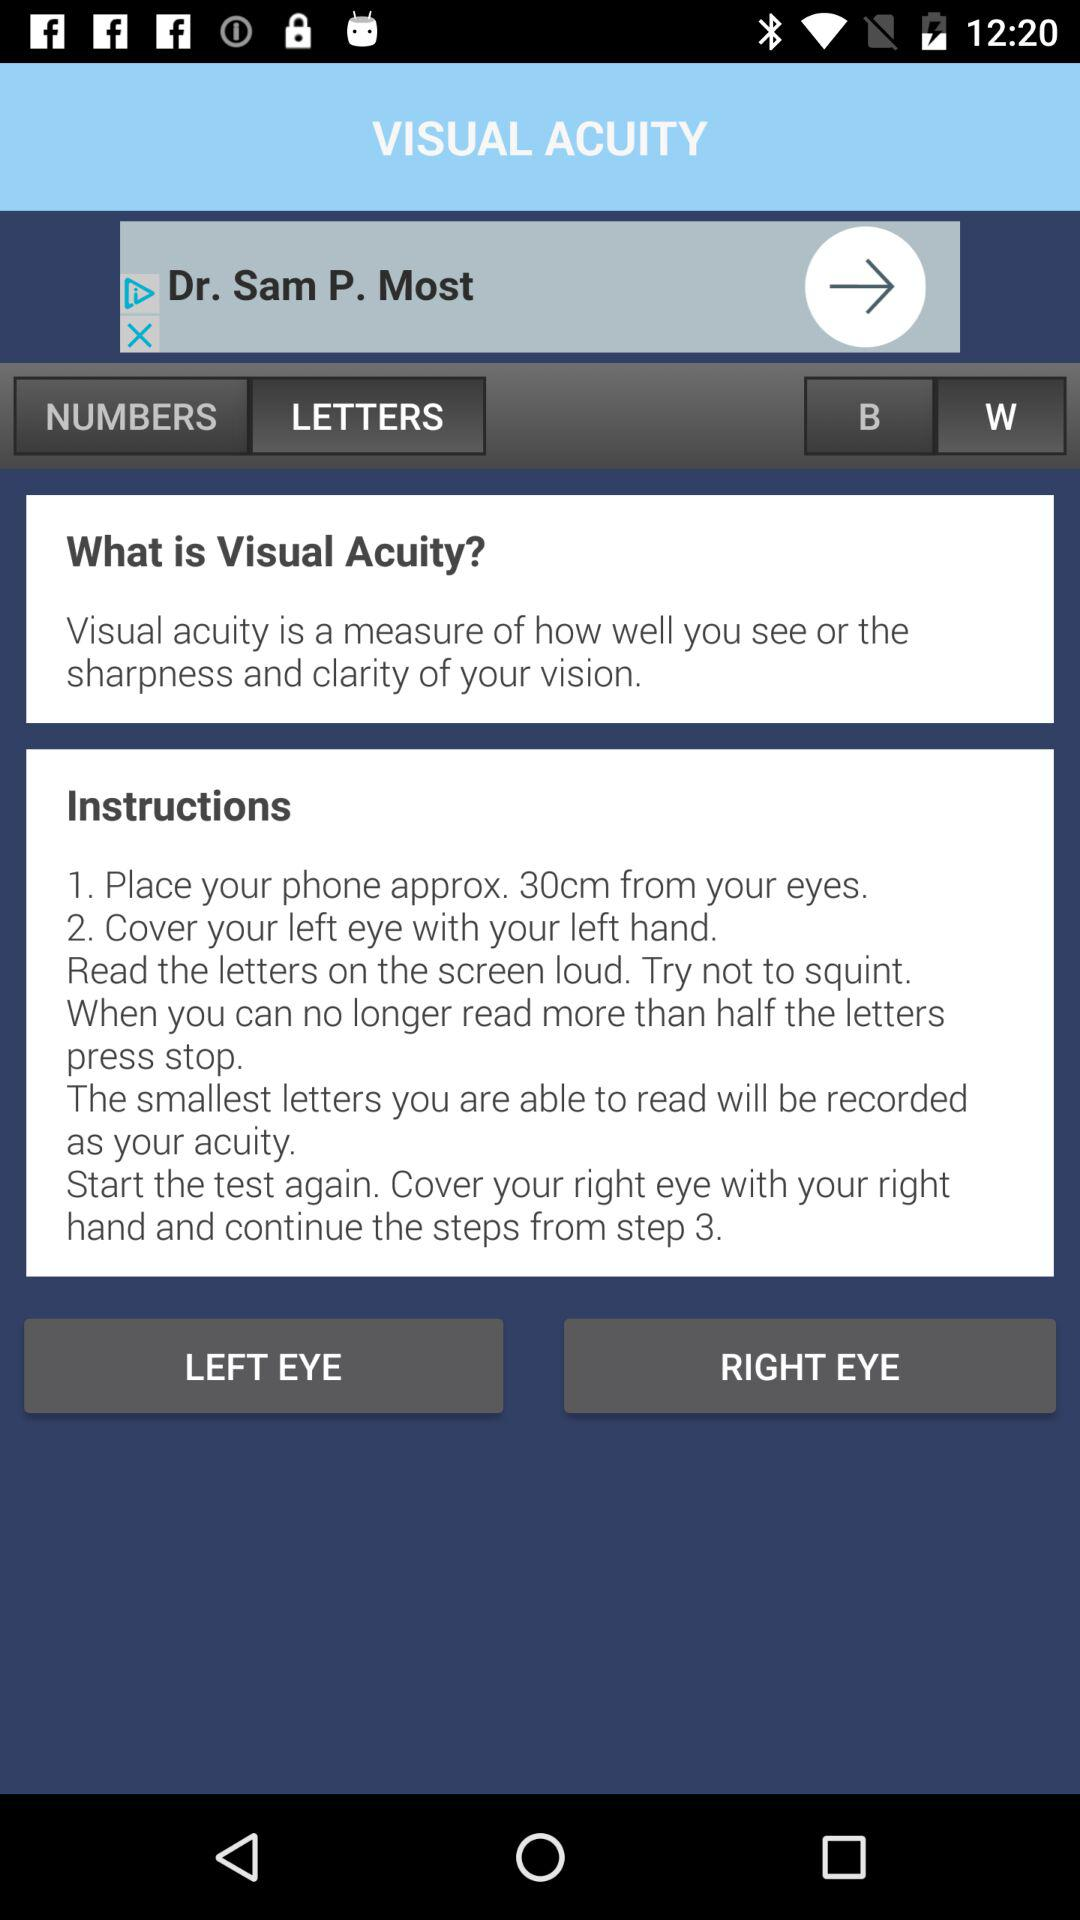What is visual acuity? Visual acuity is a measure of how well you see, or the sharpness and clarity of your vision. 